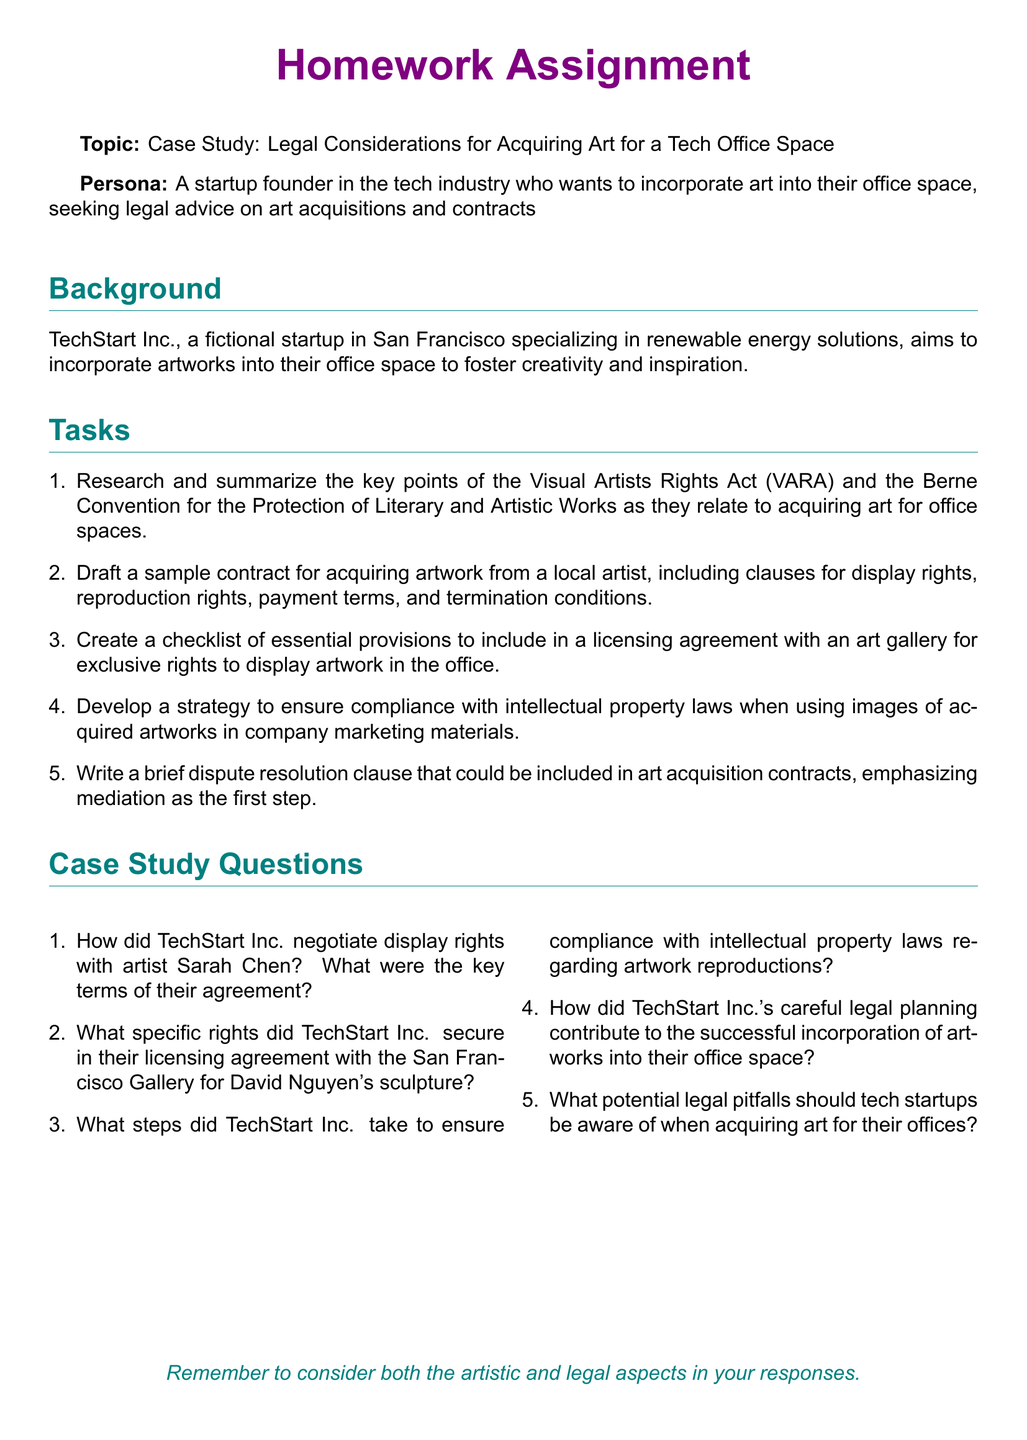What is the name of the fictional startup in the case study? The document identifies the fictional startup as TechStart Inc.
Answer: TechStart Inc What is the main focus of TechStart Inc. according to the document? The document states that TechStart Inc. specializes in renewable energy solutions.
Answer: Renewable energy solutions What legal act is mentioned in relation to acquiring art? The Visual Artists Rights Act (VARA) is mentioned as relevant to art acquisitions.
Answer: Visual Artists Rights Act (VARA) What document section outlines the tasks for the assignment? The section titled "Tasks" lists the tasks involved in the homework.
Answer: Tasks How many questions are listed under the case study questions? The document presents a total of five questions in this section.
Answer: Five What is one of the key focuses of TechStart Inc. when acquiring art? The focus is on fostering creativity and inspiration in their office space.
Answer: Fostering creativity and inspiration Which artist is mentioned in the negotiation for display rights? Sarah Chen is the artist mentioned in relation to display rights negotiation.
Answer: Sarah Chen What type of clause is suggested for inclusion in art acquisition contracts? The document suggests including a dispute resolution clause emphasizing mediation.
Answer: Dispute resolution clause What city is TechStart Inc. located in? TechStart Inc. is situated in San Francisco.
Answer: San Francisco 